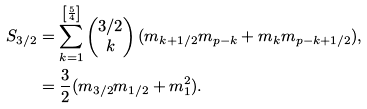<formula> <loc_0><loc_0><loc_500><loc_500>S _ { 3 / 2 } & = \sum _ { k = 1 } ^ { \left [ \frac { 5 } { 4 } \right ] } \begin{pmatrix} 3 / 2 \\ k \end{pmatrix} ( m _ { k + 1 / 2 } m _ { p - k } + m _ { k } m _ { p - k + 1 / 2 } ) , \\ & = \frac { 3 } { 2 } ( m _ { 3 / 2 } m _ { 1 / 2 } + m _ { 1 } ^ { 2 } ) .</formula> 